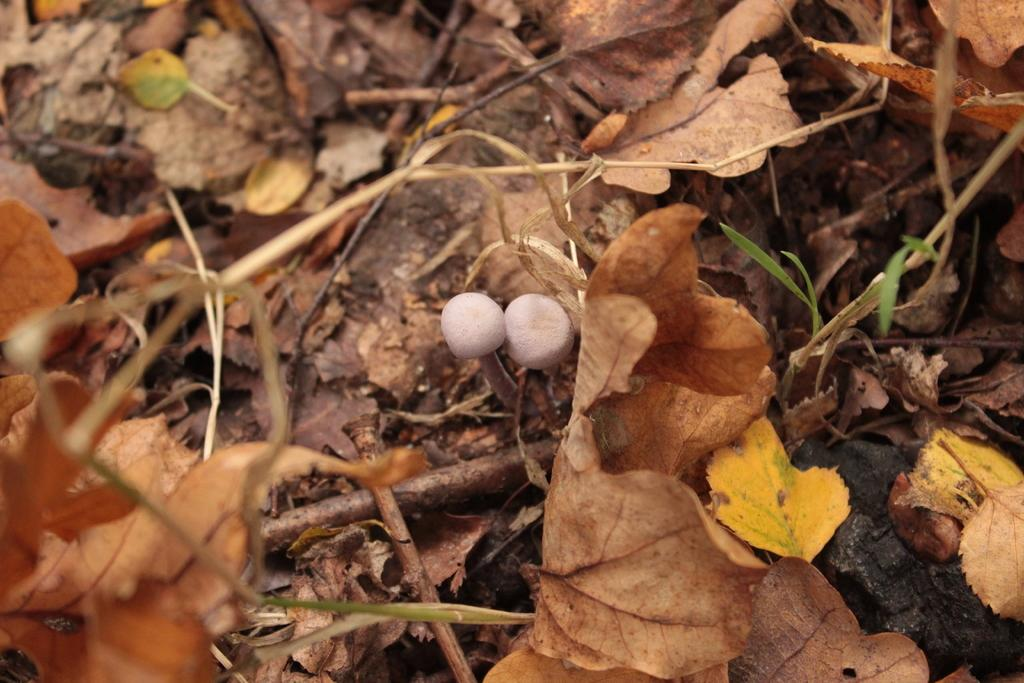What type of fungi can be seen on the ground in the image? There are white mushrooms on the ground in the image. What other natural elements can be seen in the image? There are leaves visible in the image. How many pizzas are being served in the image? There are no pizzas present in the image; it features white mushrooms and leaves. What type of container is used to carry water in the image? There is no container for carrying water, such as a pail, present in the image. 